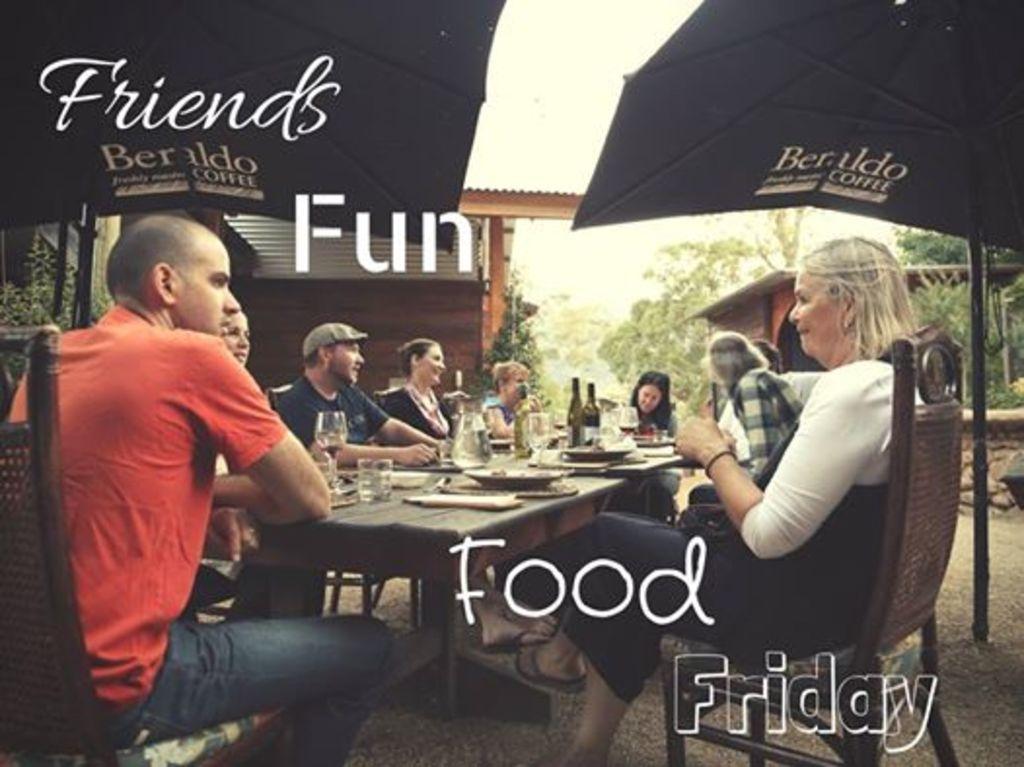In one or two sentences, can you explain what this image depicts? In this picture I can see group of people sitting on the chairs. I can see wine glasses, wine bottles, plates and some other objects on the tables. There are buildings, trees, and in the background there is the sky and there are watermarks on the image. 